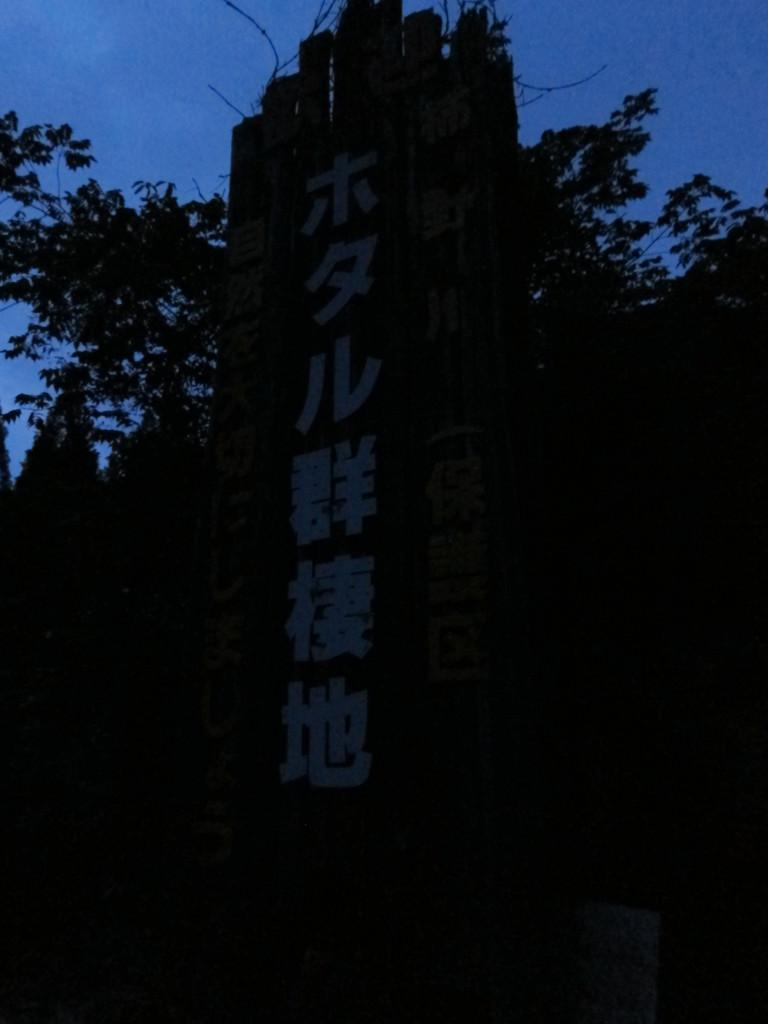What can be seen in the top portion of the image? There is a clear blue sky in the top portion of the image. What type of vegetation is present in the image? There are trees in the image. How would you describe the overall lighting in the image? The image is completely dark. What type of clouds can be seen in the image? There are no clouds visible in the image; it only features a clear blue sky. What type of milk is being poured in the image? There is no milk present in the image. Is there a bridge visible in the image? There is no bridge present in the image. 